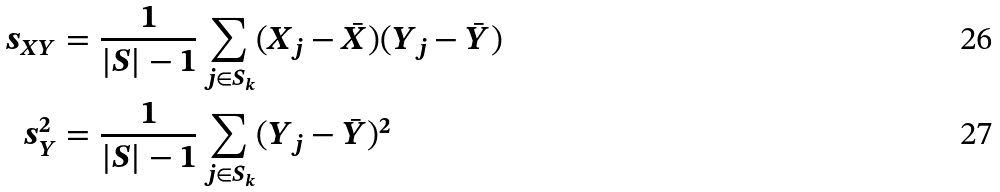Convert formula to latex. <formula><loc_0><loc_0><loc_500><loc_500>s _ { X Y } & = \frac { 1 } { | S | - 1 } \sum _ { j \in S _ { k } } ( X _ { j } - \bar { X } ) ( Y _ { j } - \bar { Y } ) \\ s _ { Y } ^ { 2 } & = \frac { 1 } { | S | - 1 } \sum _ { j \in S _ { k } } ( Y _ { j } - \bar { Y } ) ^ { 2 }</formula> 